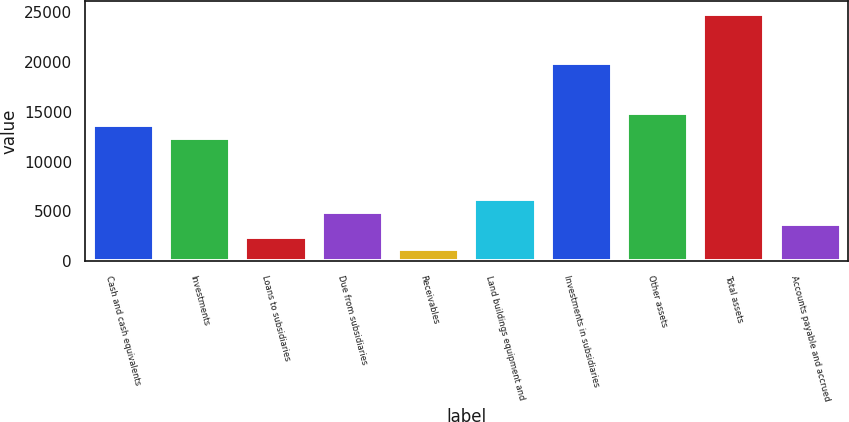Convert chart. <chart><loc_0><loc_0><loc_500><loc_500><bar_chart><fcel>Cash and cash equivalents<fcel>Investments<fcel>Loans to subsidiaries<fcel>Due from subsidiaries<fcel>Receivables<fcel>Land buildings equipment and<fcel>Investments in subsidiaries<fcel>Other assets<fcel>Total assets<fcel>Accounts payable and accrued<nl><fcel>13650.7<fcel>12410<fcel>2484.4<fcel>4965.8<fcel>1243.7<fcel>6206.5<fcel>19854.2<fcel>14891.4<fcel>24817<fcel>3725.1<nl></chart> 